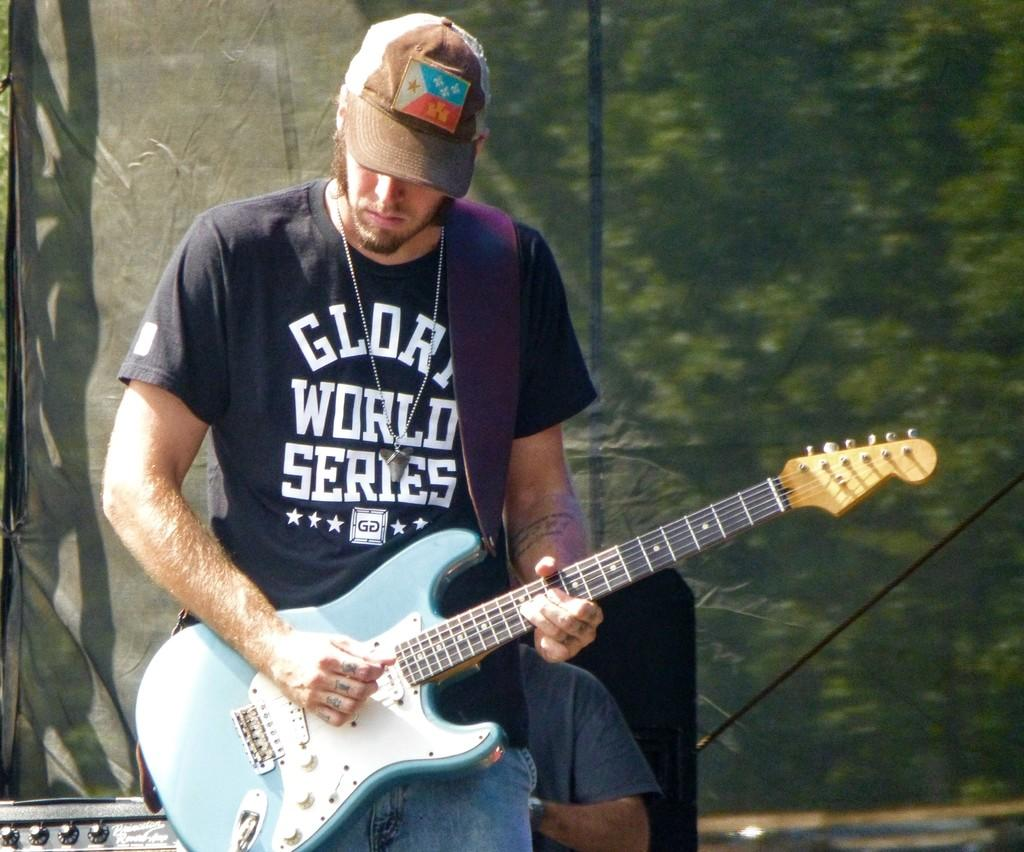Who is the main subject in the image? There is a man in the image. What is the man holding in the image? The man is holding a guitar. What is the man doing with the guitar? The man is playing the guitar. What can be seen in the background of the image? There are trees in the background of the image. Where are the ants carrying the transport in the image? There are no ants or transport present in the image. Is there a cactus visible in the image? There is no cactus visible in the image; only a man, a guitar, and trees in the background are present. 